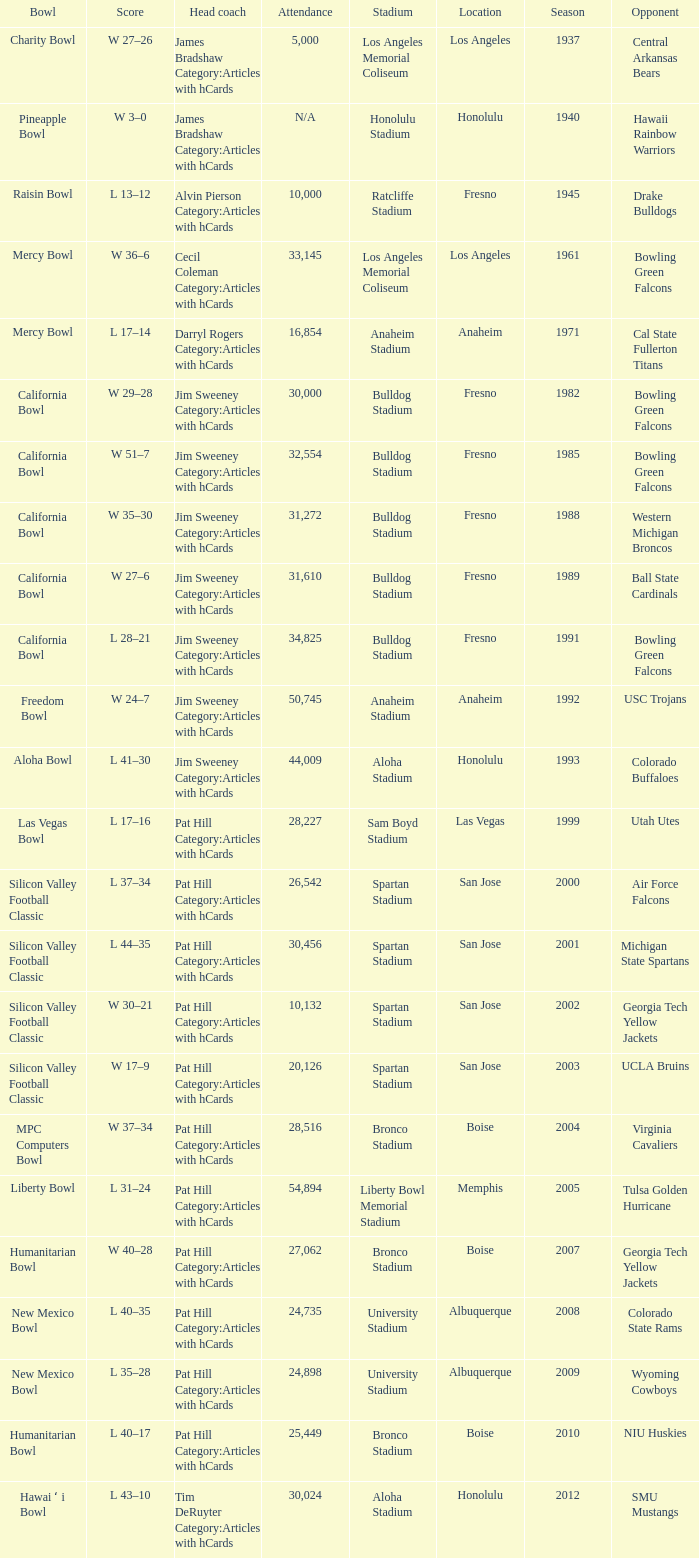What stadium had an opponent of Cal State Fullerton Titans? Anaheim Stadium. 